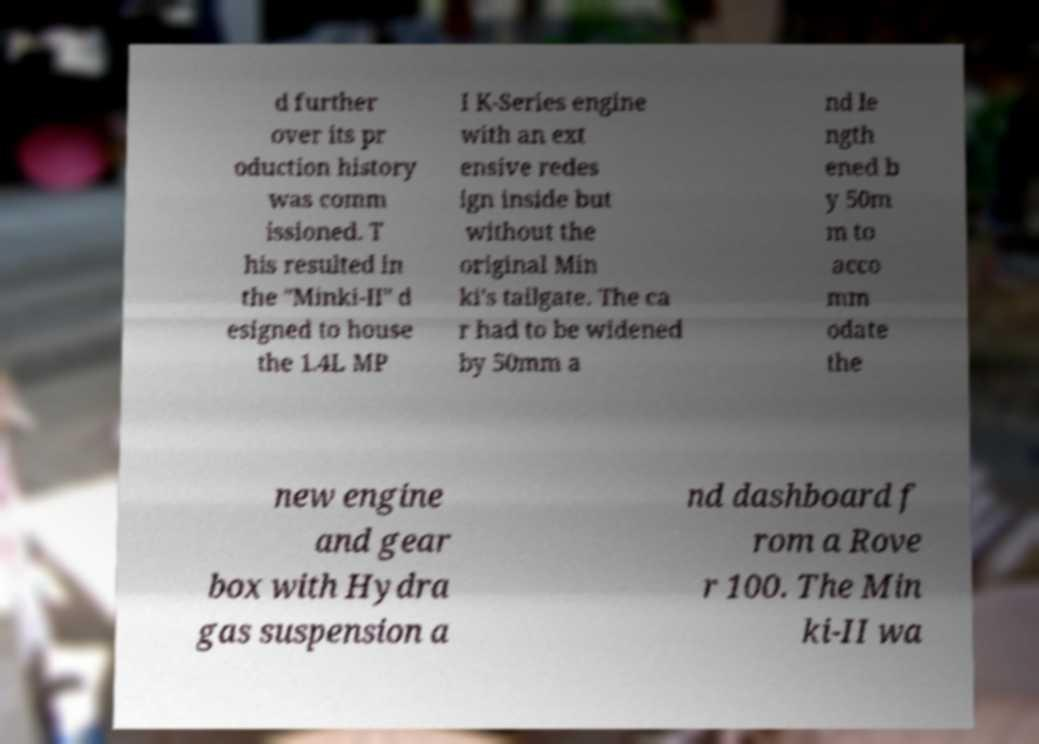For documentation purposes, I need the text within this image transcribed. Could you provide that? d further over its pr oduction history was comm issioned. T his resulted in the "Minki-II" d esigned to house the 1.4L MP I K-Series engine with an ext ensive redes ign inside but without the original Min ki's tailgate. The ca r had to be widened by 50mm a nd le ngth ened b y 50m m to acco mm odate the new engine and gear box with Hydra gas suspension a nd dashboard f rom a Rove r 100. The Min ki-II wa 